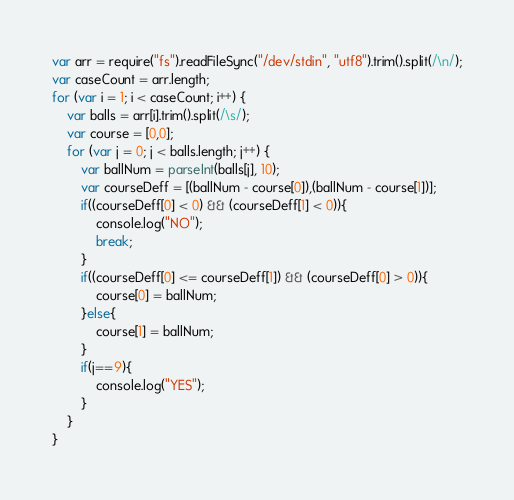Convert code to text. <code><loc_0><loc_0><loc_500><loc_500><_JavaScript_>var arr = require("fs").readFileSync("/dev/stdin", "utf8").trim().split(/\n/);
var caseCount = arr.length;
for (var i = 1; i < caseCount; i++) {
	var balls = arr[i].trim().split(/\s/);
	var course = [0,0];
	for (var j = 0; j < balls.length; j++) {
		var ballNum = parseInt(balls[j], 10);
		var courseDeff = [(ballNum - course[0]),(ballNum - course[1])];
		if((courseDeff[0] < 0) && (courseDeff[1] < 0)){
			console.log("NO");
			break;
		}
		if((courseDeff[0] <= courseDeff[1]) && (courseDeff[0] > 0)){
			course[0] = ballNum;
		}else{
			course[1] = ballNum;
		}
		if(j==9){
			console.log("YES");
		}
	}
}</code> 